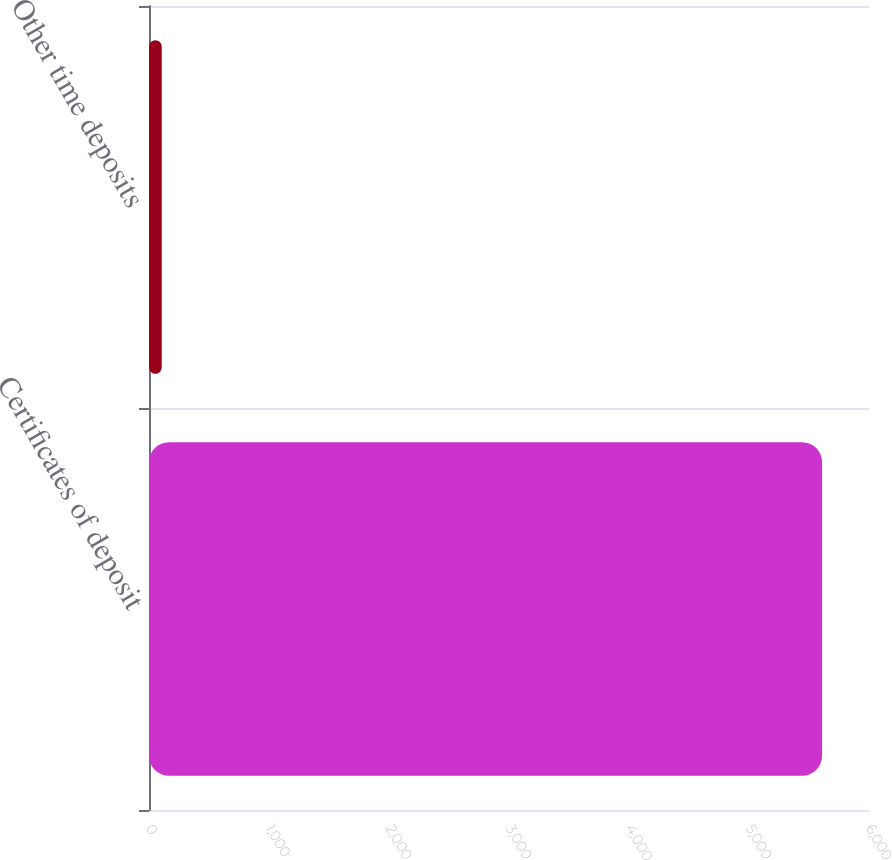Convert chart. <chart><loc_0><loc_0><loc_500><loc_500><bar_chart><fcel>Certificates of deposit<fcel>Other time deposits<nl><fcel>5609<fcel>106<nl></chart> 